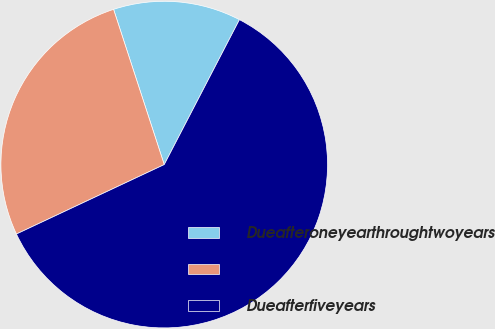<chart> <loc_0><loc_0><loc_500><loc_500><pie_chart><fcel>Dueafteroneyearthroughtwoyears<fcel>Unnamed: 1<fcel>Dueafterfiveyears<nl><fcel>12.64%<fcel>26.97%<fcel>60.39%<nl></chart> 